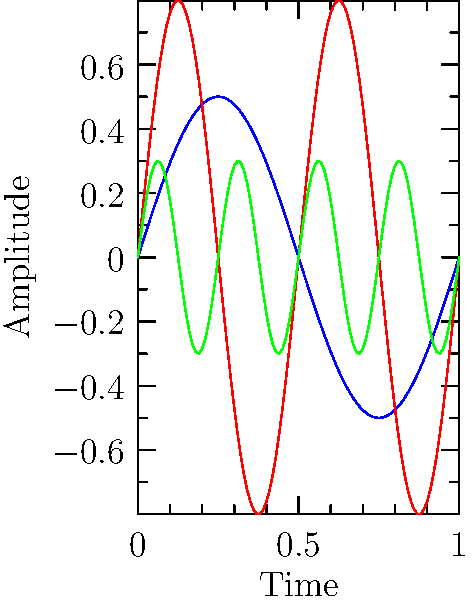As an aspiring songwriter, you're exploring different instrument sounds. Looking at the waveform patterns above, which instrument is likely to have the highest pitch? To determine which instrument has the highest pitch, we need to analyze the frequency of each waveform:

1. Frequency is related to the number of cycles completed in a given time period.
2. In this graph, we can see one complete cycle for each instrument:
   - Instrument A (blue): completes 1 cycle
   - Instrument B (red): completes 2 cycles
   - Instrument C (green): completes 4 cycles
3. More cycles in the same time period indicate a higher frequency.
4. Higher frequency corresponds to higher pitch.
5. Therefore, Instrument C, with the most cycles, has the highest frequency and thus the highest pitch.

This understanding can help you as a songwriter to choose instruments that complement each other based on their pitch characteristics.
Answer: Instrument C 